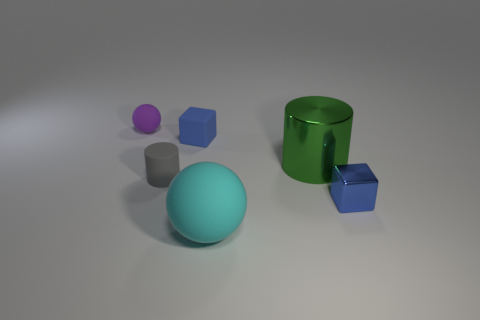Subtract all yellow cylinders. Subtract all yellow cubes. How many cylinders are left? 2 Add 4 metal things. How many objects exist? 10 Subtract all cylinders. How many objects are left? 4 Subtract all matte cubes. Subtract all big red metal cubes. How many objects are left? 5 Add 3 rubber blocks. How many rubber blocks are left? 4 Add 5 red matte spheres. How many red matte spheres exist? 5 Subtract 0 blue spheres. How many objects are left? 6 